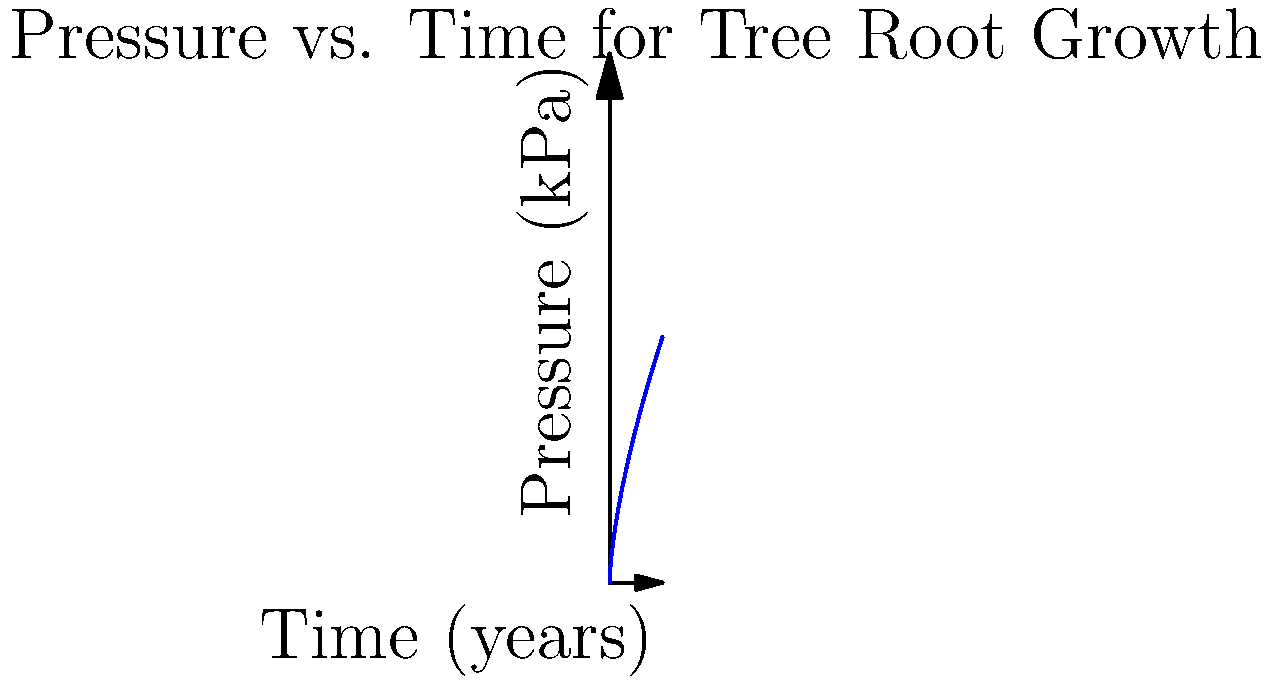A century-old oak tree grows near a cherished burial plot. The graph shows the pressure exerted by its roots on the surrounding soil over time. If the pressure follows the equation $P = 10t^{2/3}$, where $P$ is pressure in kPa and $t$ is time in years, calculate the rate of change of pressure at 8 years. How might this affect the preservation of nearby headstones? To find the rate of change of pressure at 8 years, we need to follow these steps:

1) The given equation for pressure is $P = 10t^{2/3}$

2) To find the rate of change, we need to differentiate this equation with respect to time:

   $\frac{dP}{dt} = 10 \cdot \frac{2}{3} \cdot t^{-1/3}$

3) Simplify:
   
   $\frac{dP}{dt} = \frac{20}{3} \cdot t^{-1/3}$

4) Now, we substitute t = 8 into this equation:

   $\frac{dP}{dt}|_{t=8} = \frac{20}{3} \cdot 8^{-1/3}$

5) Calculate:
   
   $\frac{dP}{dt}|_{t=8} = \frac{20}{3} \cdot 0.5 = \frac{10}{3} \approx 3.33$ kPa/year

This rate of pressure increase could potentially cause slow but steady displacement of nearby headstones over time, affecting their stability and preservation. It emphasizes the need for regular maintenance and possibly implementing root barriers to protect the integrity of the burial plots.
Answer: $\frac{10}{3}$ kPa/year 